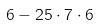Convert formula to latex. <formula><loc_0><loc_0><loc_500><loc_500>6 - 2 5 \cdot 7 \cdot 6</formula> 